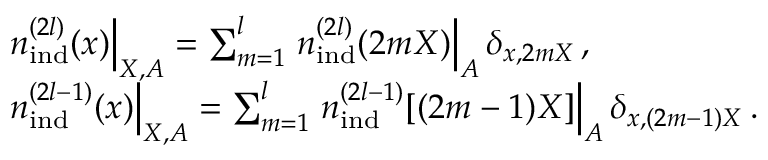<formula> <loc_0><loc_0><loc_500><loc_500>\begin{array} { r l } & { { n } _ { i n d } ^ { ( 2 l ) } ( x ) \right | _ { X , A } = \sum _ { m = 1 } ^ { l } { n } _ { i n d } ^ { ( 2 l ) } ( 2 m X ) \right | _ { A } \delta _ { x , 2 m X } \, , } \\ & { { n } _ { i n d } ^ { ( 2 l - 1 ) } ( x ) \right | _ { X , A } = \sum _ { m = 1 } ^ { l } { n } _ { i n d } ^ { ( 2 l - 1 ) } [ ( 2 m - 1 ) X ] \right | _ { A } \delta _ { x , ( 2 m - 1 ) X } \, . } \end{array}</formula> 